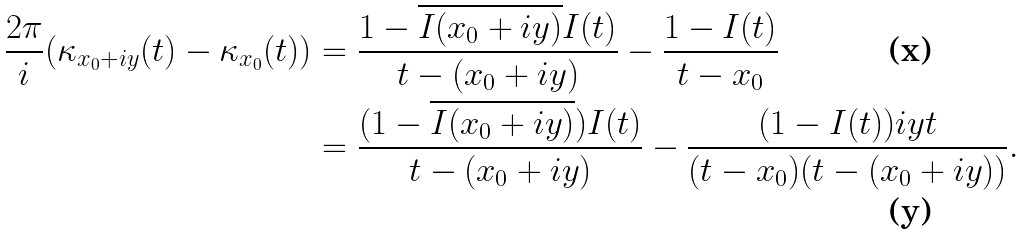<formula> <loc_0><loc_0><loc_500><loc_500>\frac { 2 \pi } { i } ( \kappa _ { x _ { 0 } + i y } ( t ) - \kappa _ { x _ { 0 } } ( t ) ) & = \frac { 1 - \overline { I ( x _ { 0 } + i y ) } I ( t ) } { t - ( x _ { 0 } + i y ) } - \frac { 1 - I ( t ) } { t - x _ { 0 } } \\ & = \frac { ( 1 - \overline { I ( x _ { 0 } + i y ) } ) I ( t ) } { t - ( x _ { 0 } + i y ) } - \frac { ( 1 - I ( t ) ) i y t } { ( t - x _ { 0 } ) ( t - ( x _ { 0 } + i y ) ) } .</formula> 